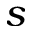<formula> <loc_0><loc_0><loc_500><loc_500>s</formula> 